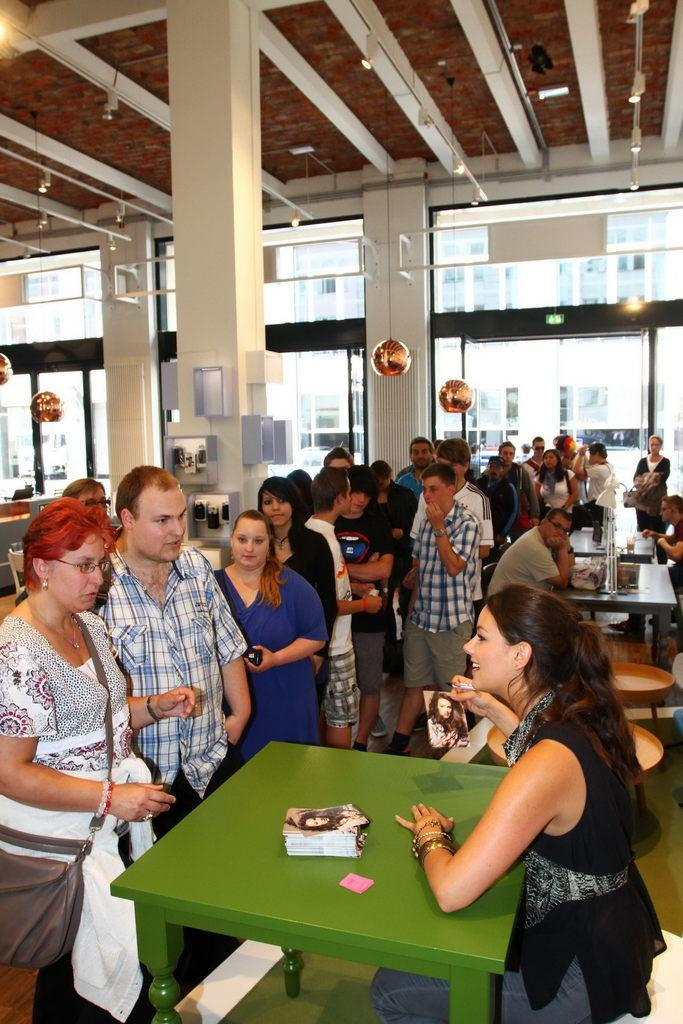What are the people in the room doing? The people in the room are standing in a line. What else can be seen in the room? There is a table and a woman seated on a chair in the room. What is the woman doing? The woman is speaking to the people standing in line. What color is the gold bat that the woman is holding in the image? There is no gold bat present in the image; the woman is simply speaking to the people standing in line. 